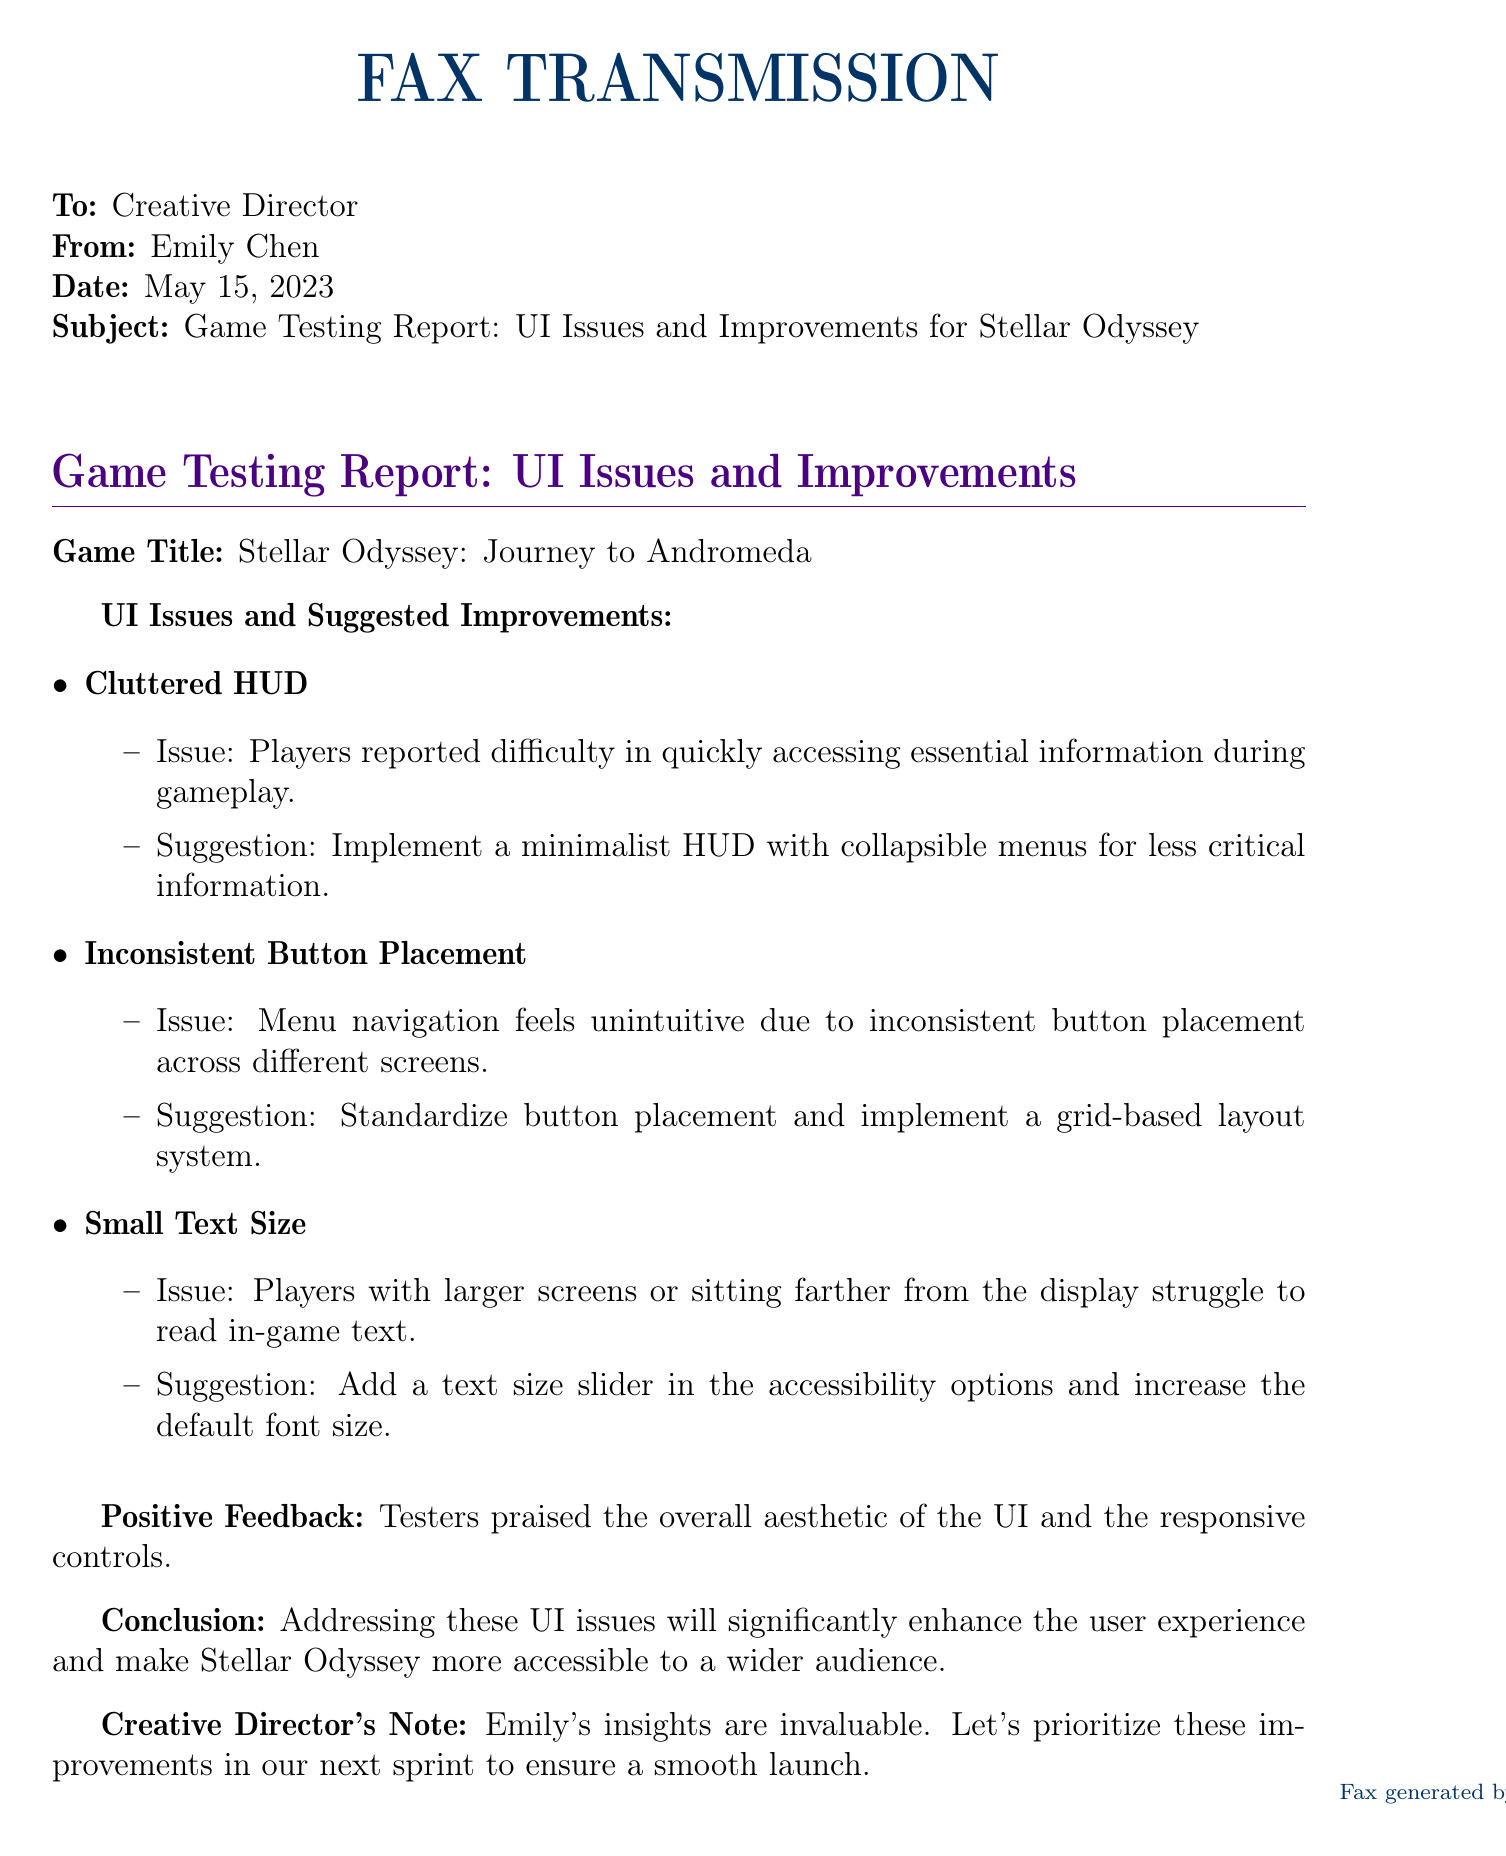What is the game title? The game title is stated at the beginning of the report under "Game Title".
Answer: Stellar Odyssey: Journey to Andromeda Who is the sender of the fax? The sender's name is mentioned at the beginning of the fax.
Answer: Emily Chen What date was the fax sent? The fax date is specified near the top of the document.
Answer: May 15, 2023 What is one of the UI issues reported? The UI issues are listed in bullet points; one of them is specifically mentioned.
Answer: Cluttered HUD What improvement is suggested for text size? The suggested improvement for text size is stated in the related section of the document.
Answer: Add a text size slider How many positive feedback points are mentioned? The document mentions that testers praised the overall aesthetic and controls, indicating the count.
Answer: One What is the custom color used in the document? The specific color used in the document is mentioned by name.
Answer: spaceblue What is suggested for button placement consistency? The suggestion for button placement consistency is found within the relevant point discussed.
Answer: Implement a grid-based layout system What overall impression did the testers have about the UI? The overall feedback from the testers is summarized in the positive feedback section.
Answer: Praised the overall aesthetic What is the conclusion of the report? The conclusion summarizes the report's intent and is directly quoted at the end.
Answer: Enhance the user experience 